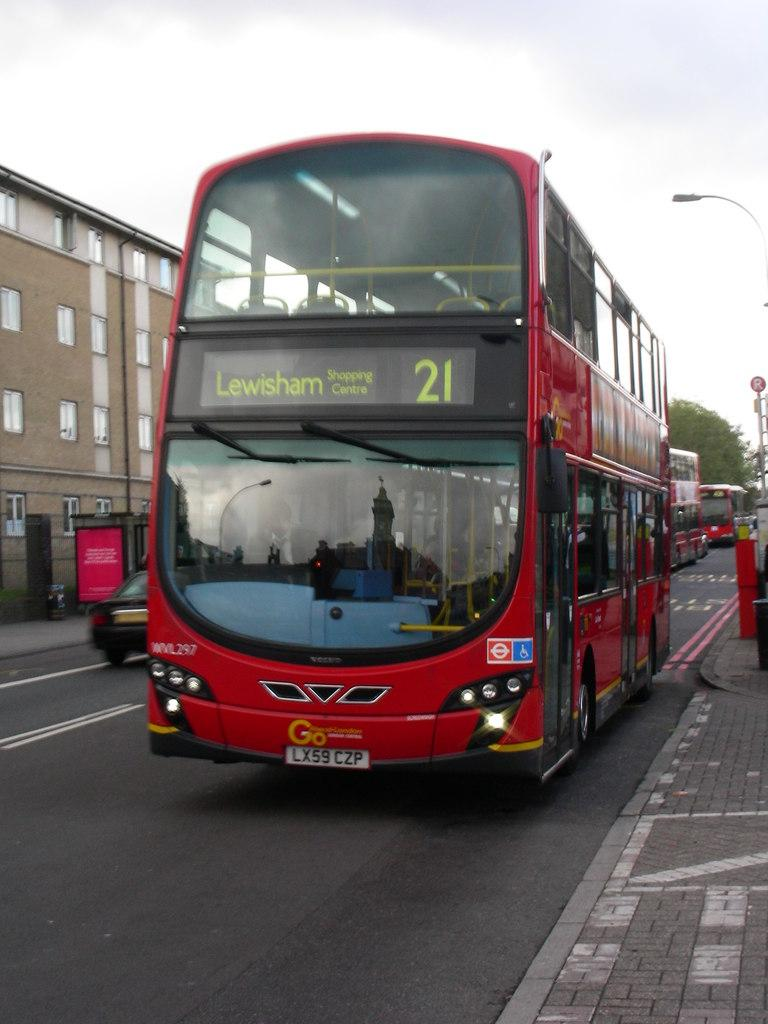<image>
Create a compact narrative representing the image presented. A red double decker bus with the 21 displayed. 